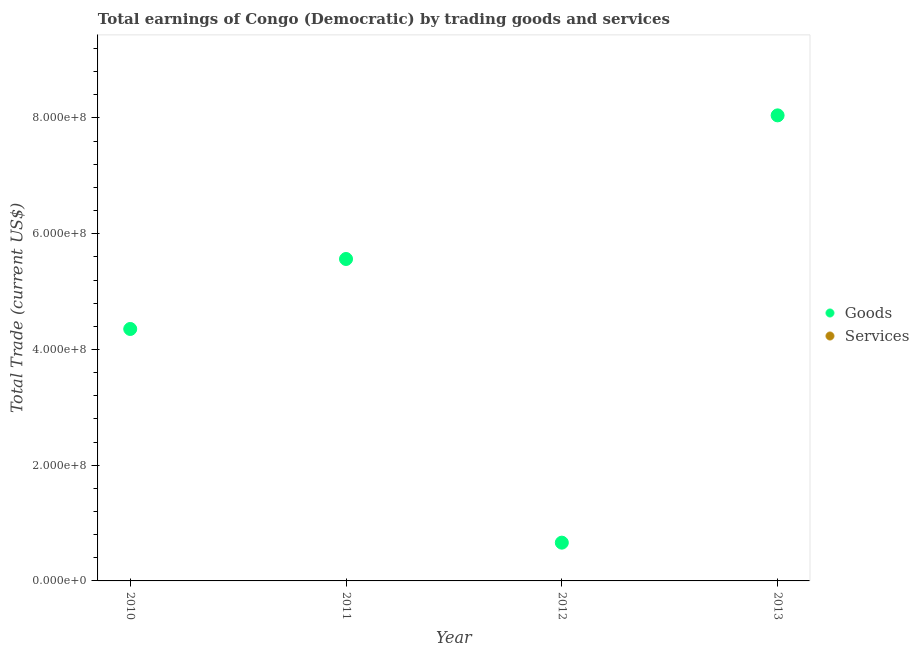How many different coloured dotlines are there?
Keep it short and to the point. 1. What is the amount earned by trading services in 2013?
Give a very brief answer. 0. Across all years, what is the maximum amount earned by trading goods?
Make the answer very short. 8.05e+08. Across all years, what is the minimum amount earned by trading goods?
Give a very brief answer. 6.61e+07. What is the total amount earned by trading goods in the graph?
Keep it short and to the point. 1.86e+09. What is the difference between the amount earned by trading goods in 2011 and that in 2012?
Your response must be concise. 4.90e+08. What is the difference between the amount earned by trading goods in 2010 and the amount earned by trading services in 2013?
Make the answer very short. 4.35e+08. In how many years, is the amount earned by trading goods greater than 840000000 US$?
Keep it short and to the point. 0. What is the ratio of the amount earned by trading goods in 2010 to that in 2012?
Ensure brevity in your answer.  6.58. What is the difference between the highest and the second highest amount earned by trading goods?
Ensure brevity in your answer.  2.48e+08. What is the difference between the highest and the lowest amount earned by trading goods?
Your answer should be very brief. 7.38e+08. Does the amount earned by trading services monotonically increase over the years?
Your answer should be compact. No. Is the amount earned by trading goods strictly greater than the amount earned by trading services over the years?
Keep it short and to the point. Yes. Is the amount earned by trading services strictly less than the amount earned by trading goods over the years?
Offer a terse response. Yes. How many years are there in the graph?
Give a very brief answer. 4. Does the graph contain any zero values?
Give a very brief answer. Yes. How many legend labels are there?
Your response must be concise. 2. How are the legend labels stacked?
Ensure brevity in your answer.  Vertical. What is the title of the graph?
Offer a terse response. Total earnings of Congo (Democratic) by trading goods and services. Does "Male" appear as one of the legend labels in the graph?
Keep it short and to the point. No. What is the label or title of the X-axis?
Your response must be concise. Year. What is the label or title of the Y-axis?
Offer a very short reply. Total Trade (current US$). What is the Total Trade (current US$) in Goods in 2010?
Your answer should be very brief. 4.35e+08. What is the Total Trade (current US$) of Goods in 2011?
Make the answer very short. 5.56e+08. What is the Total Trade (current US$) in Goods in 2012?
Make the answer very short. 6.61e+07. What is the Total Trade (current US$) of Services in 2012?
Provide a short and direct response. 0. What is the Total Trade (current US$) of Goods in 2013?
Offer a very short reply. 8.05e+08. Across all years, what is the maximum Total Trade (current US$) of Goods?
Offer a very short reply. 8.05e+08. Across all years, what is the minimum Total Trade (current US$) of Goods?
Give a very brief answer. 6.61e+07. What is the total Total Trade (current US$) in Goods in the graph?
Provide a short and direct response. 1.86e+09. What is the total Total Trade (current US$) in Services in the graph?
Keep it short and to the point. 0. What is the difference between the Total Trade (current US$) of Goods in 2010 and that in 2011?
Your response must be concise. -1.21e+08. What is the difference between the Total Trade (current US$) of Goods in 2010 and that in 2012?
Ensure brevity in your answer.  3.69e+08. What is the difference between the Total Trade (current US$) in Goods in 2010 and that in 2013?
Give a very brief answer. -3.69e+08. What is the difference between the Total Trade (current US$) in Goods in 2011 and that in 2012?
Your answer should be very brief. 4.90e+08. What is the difference between the Total Trade (current US$) of Goods in 2011 and that in 2013?
Your answer should be compact. -2.48e+08. What is the difference between the Total Trade (current US$) of Goods in 2012 and that in 2013?
Provide a short and direct response. -7.38e+08. What is the average Total Trade (current US$) in Goods per year?
Ensure brevity in your answer.  4.66e+08. What is the average Total Trade (current US$) of Services per year?
Provide a succinct answer. 0. What is the ratio of the Total Trade (current US$) in Goods in 2010 to that in 2011?
Your response must be concise. 0.78. What is the ratio of the Total Trade (current US$) in Goods in 2010 to that in 2012?
Give a very brief answer. 6.58. What is the ratio of the Total Trade (current US$) in Goods in 2010 to that in 2013?
Offer a terse response. 0.54. What is the ratio of the Total Trade (current US$) in Goods in 2011 to that in 2012?
Make the answer very short. 8.41. What is the ratio of the Total Trade (current US$) in Goods in 2011 to that in 2013?
Keep it short and to the point. 0.69. What is the ratio of the Total Trade (current US$) in Goods in 2012 to that in 2013?
Make the answer very short. 0.08. What is the difference between the highest and the second highest Total Trade (current US$) in Goods?
Offer a very short reply. 2.48e+08. What is the difference between the highest and the lowest Total Trade (current US$) in Goods?
Ensure brevity in your answer.  7.38e+08. 